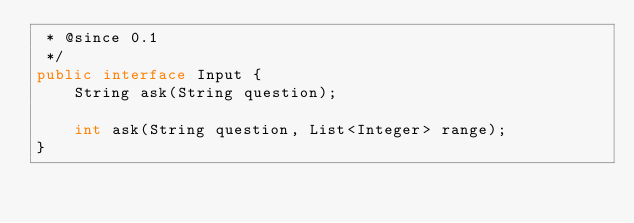<code> <loc_0><loc_0><loc_500><loc_500><_Java_> * @since 0.1
 */
public interface Input {
    String ask(String question);

    int ask(String question, List<Integer> range);
}
</code> 